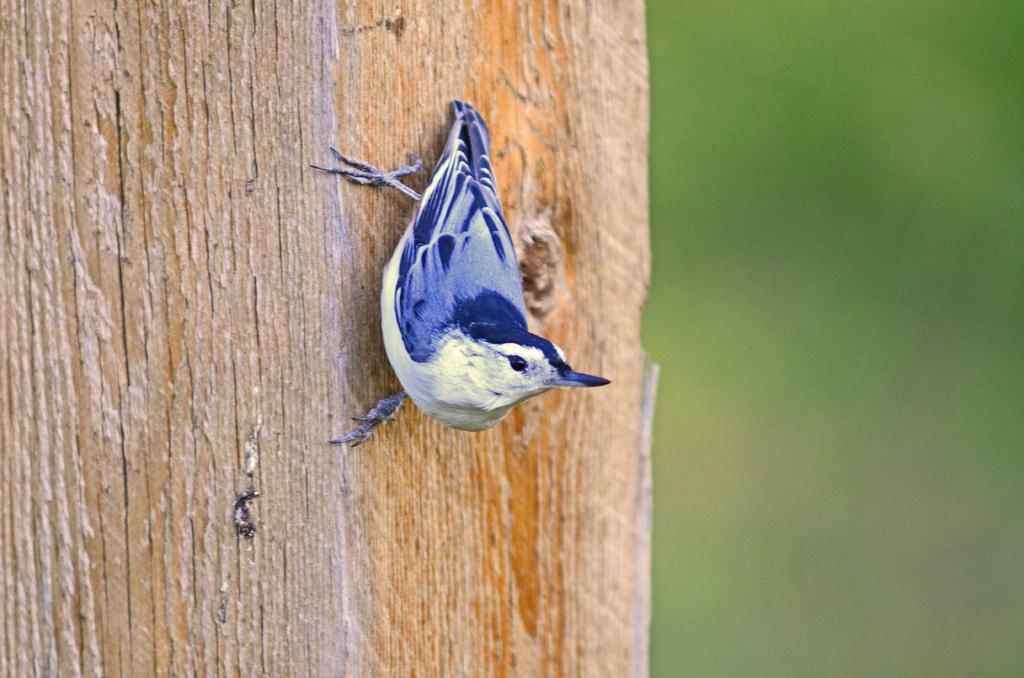What type of animal is in the image? There is a bird in the image. Where is the bird located? The bird is on a wooden surface. What type of business is being conducted in the image? There is no indication of any business being conducted in the image; it features a bird on a wooden surface. What action is the bird performing in the image? The facts provided do not specify any action being performed by the bird in the image. 